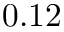<formula> <loc_0><loc_0><loc_500><loc_500>0 . 1 2</formula> 